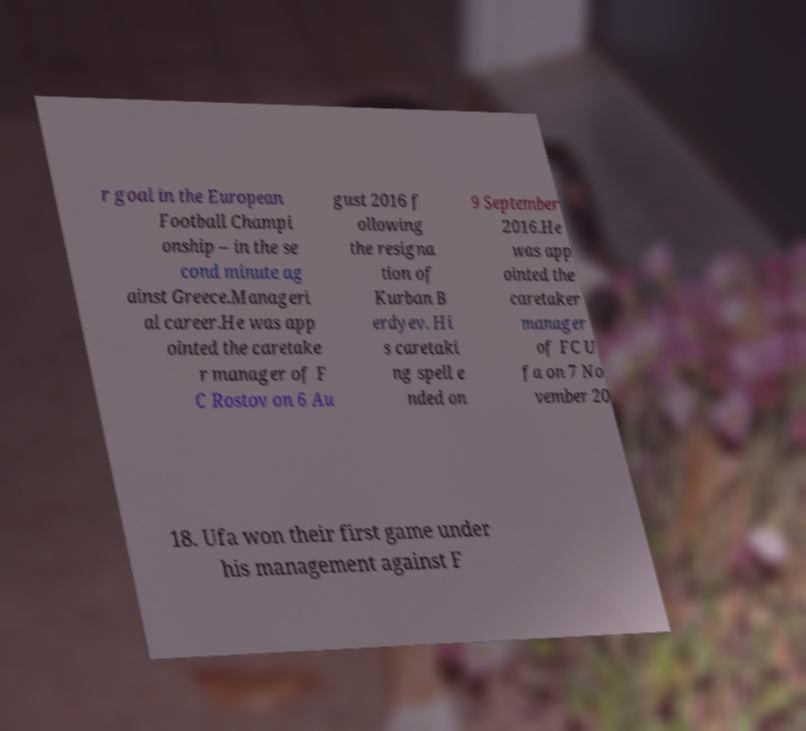Could you extract and type out the text from this image? r goal in the European Football Champi onship – in the se cond minute ag ainst Greece.Manageri al career.He was app ointed the caretake r manager of F C Rostov on 6 Au gust 2016 f ollowing the resigna tion of Kurban B erdyev. Hi s caretaki ng spell e nded on 9 September 2016.He was app ointed the caretaker manager of FC U fa on 7 No vember 20 18. Ufa won their first game under his management against F 